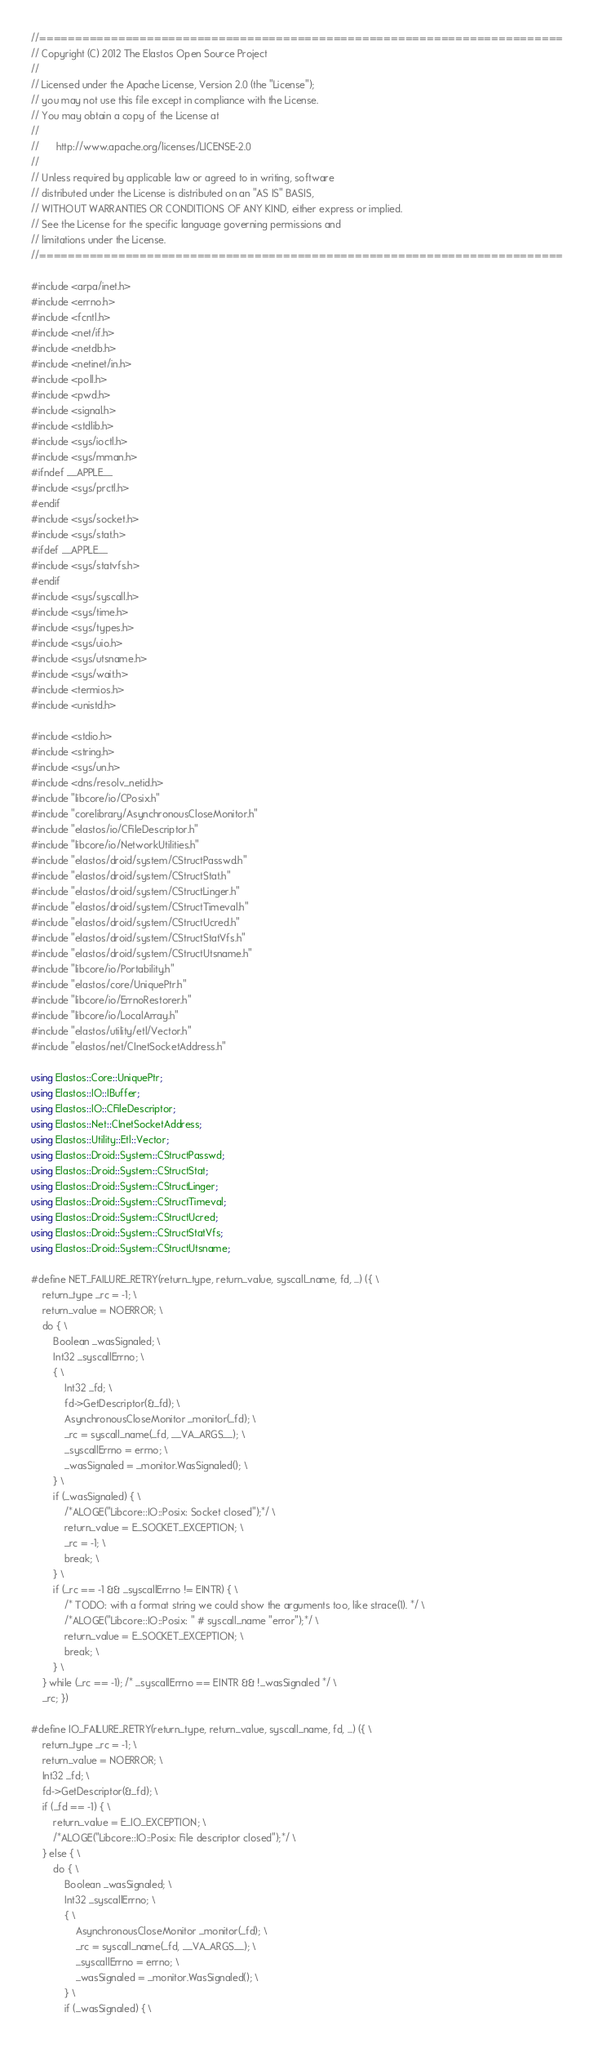Convert code to text. <code><loc_0><loc_0><loc_500><loc_500><_C++_>//=========================================================================
// Copyright (C) 2012 The Elastos Open Source Project
//
// Licensed under the Apache License, Version 2.0 (the "License");
// you may not use this file except in compliance with the License.
// You may obtain a copy of the License at
//
//      http://www.apache.org/licenses/LICENSE-2.0
//
// Unless required by applicable law or agreed to in writing, software
// distributed under the License is distributed on an "AS IS" BASIS,
// WITHOUT WARRANTIES OR CONDITIONS OF ANY KIND, either express or implied.
// See the License for the specific language governing permissions and
// limitations under the License.
//=========================================================================

#include <arpa/inet.h>
#include <errno.h>
#include <fcntl.h>
#include <net/if.h>
#include <netdb.h>
#include <netinet/in.h>
#include <poll.h>
#include <pwd.h>
#include <signal.h>
#include <stdlib.h>
#include <sys/ioctl.h>
#include <sys/mman.h>
#ifndef __APPLE__
#include <sys/prctl.h>
#endif
#include <sys/socket.h>
#include <sys/stat.h>
#ifdef __APPLE__
#include <sys/statvfs.h>
#endif
#include <sys/syscall.h>
#include <sys/time.h>
#include <sys/types.h>
#include <sys/uio.h>
#include <sys/utsname.h>
#include <sys/wait.h>
#include <termios.h>
#include <unistd.h>

#include <stdio.h>
#include <string.h>
#include <sys/un.h>
#include <dns/resolv_netid.h>
#include "libcore/io/CPosix.h"
#include "corelibrary/AsynchronousCloseMonitor.h"
#include "elastos/io/CFileDescriptor.h"
#include "libcore/io/NetworkUtilities.h"
#include "elastos/droid/system/CStructPasswd.h"
#include "elastos/droid/system/CStructStat.h"
#include "elastos/droid/system/CStructLinger.h"
#include "elastos/droid/system/CStructTimeval.h"
#include "elastos/droid/system/CStructUcred.h"
#include "elastos/droid/system/CStructStatVfs.h"
#include "elastos/droid/system/CStructUtsname.h"
#include "libcore/io/Portability.h"
#include "elastos/core/UniquePtr.h"
#include "libcore/io/ErrnoRestorer.h"
#include "libcore/io/LocalArray.h"
#include "elastos/utility/etl/Vector.h"
#include "elastos/net/CInetSocketAddress.h"

using Elastos::Core::UniquePtr;
using Elastos::IO::IBuffer;
using Elastos::IO::CFileDescriptor;
using Elastos::Net::CInetSocketAddress;
using Elastos::Utility::Etl::Vector;
using Elastos::Droid::System::CStructPasswd;
using Elastos::Droid::System::CStructStat;
using Elastos::Droid::System::CStructLinger;
using Elastos::Droid::System::CStructTimeval;
using Elastos::Droid::System::CStructUcred;
using Elastos::Droid::System::CStructStatVfs;
using Elastos::Droid::System::CStructUtsname;

#define NET_FAILURE_RETRY(return_type, return_value, syscall_name, fd, ...) ({ \
    return_type _rc = -1; \
    return_value = NOERROR; \
    do { \
        Boolean _wasSignaled; \
        Int32 _syscallErrno; \
        { \
            Int32 _fd; \
            fd->GetDescriptor(&_fd); \
            AsynchronousCloseMonitor _monitor(_fd); \
            _rc = syscall_name(_fd, __VA_ARGS__); \
            _syscallErrno = errno; \
            _wasSignaled = _monitor.WasSignaled(); \
        } \
        if (_wasSignaled) { \
            /*ALOGE("Libcore::IO::Posix: Socket closed");*/ \
            return_value = E_SOCKET_EXCEPTION; \
            _rc = -1; \
            break; \
        } \
        if (_rc == -1 && _syscallErrno != EINTR) { \
            /* TODO: with a format string we could show the arguments too, like strace(1). */ \
            /*ALOGE("Libcore::IO::Posix: " # syscall_name "error");*/ \
            return_value = E_SOCKET_EXCEPTION; \
            break; \
        } \
    } while (_rc == -1); /* _syscallErrno == EINTR && !_wasSignaled */ \
    _rc; })

#define IO_FAILURE_RETRY(return_type, return_value, syscall_name, fd, ...) ({ \
    return_type _rc = -1; \
    return_value = NOERROR; \
    Int32 _fd; \
    fd->GetDescriptor(&_fd); \
    if (_fd == -1) { \
        return_value = E_IO_EXCEPTION; \
        /*ALOGE("Libcore::IO::Posix: File descriptor closed");*/ \
    } else { \
        do { \
            Boolean _wasSignaled; \
            Int32 _syscallErrno; \
            { \
                AsynchronousCloseMonitor _monitor(_fd); \
                _rc = syscall_name(_fd, __VA_ARGS__); \
                _syscallErrno = errno; \
                _wasSignaled = _monitor.WasSignaled(); \
            } \
            if (_wasSignaled) { \</code> 